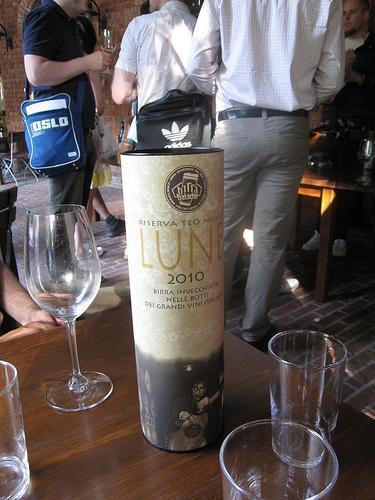How many classes are to the left of the bottle?
Give a very brief answer. 1. 